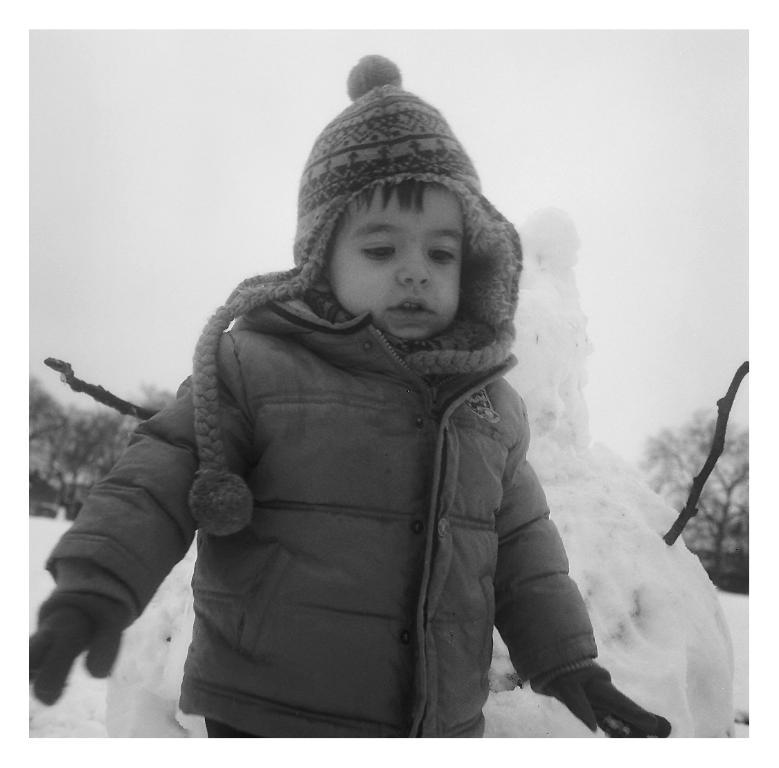Who or what is the main subject in the image? There is a person in the image. What is the person wearing? The person is wearing a dress. What can be seen in the background of the image? There is snow, sticks, trees, and the sky visible in the background of the image. What type of juice is being served in the image? There is no juice present in the image. What property does the person own in the image? The image does not show any property owned by the person. 